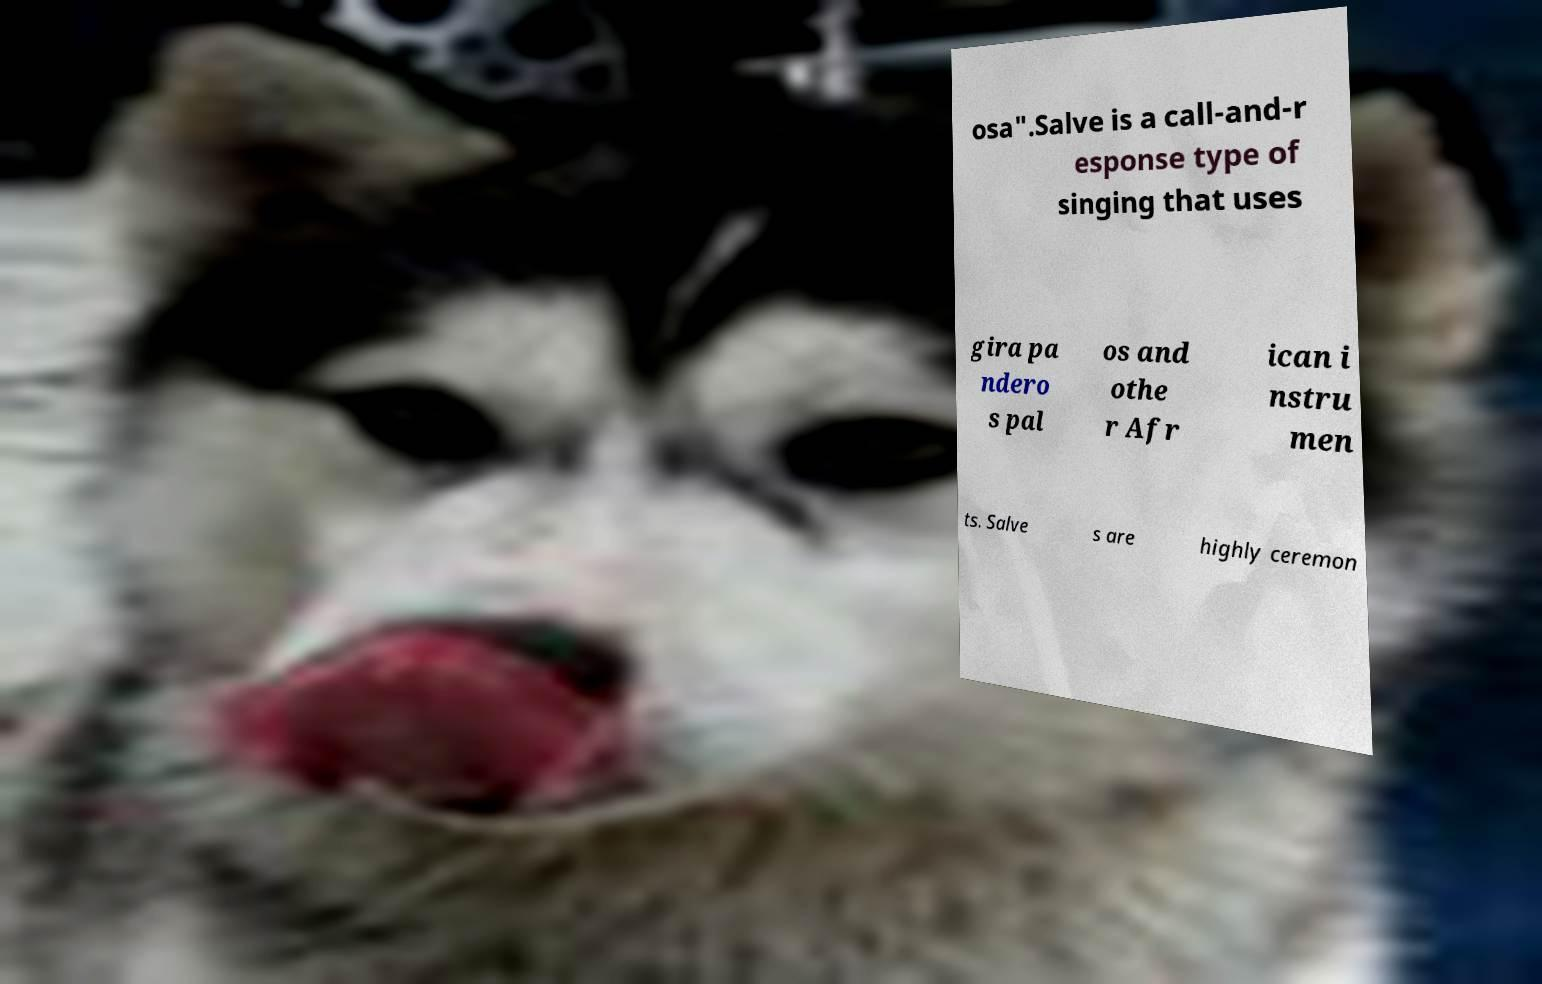I need the written content from this picture converted into text. Can you do that? osa".Salve is a call-and-r esponse type of singing that uses gira pa ndero s pal os and othe r Afr ican i nstru men ts. Salve s are highly ceremon 